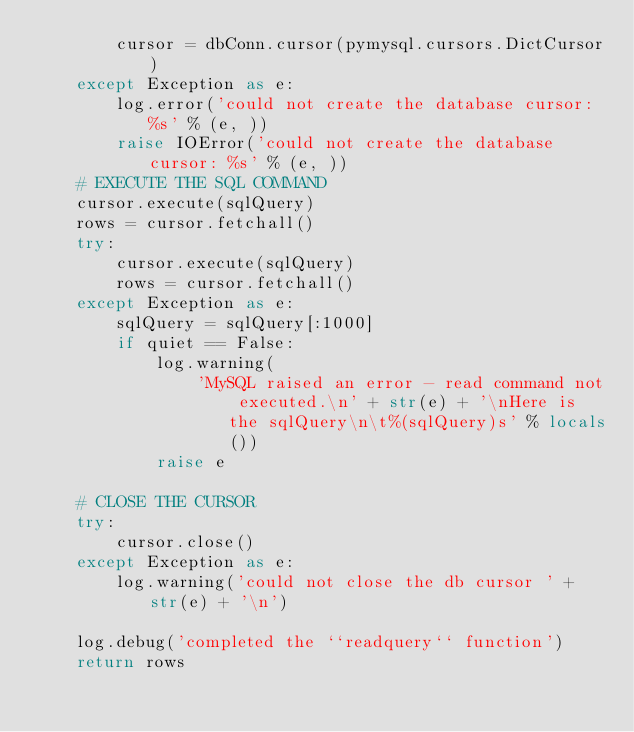<code> <loc_0><loc_0><loc_500><loc_500><_Python_>        cursor = dbConn.cursor(pymysql.cursors.DictCursor)
    except Exception as e:
        log.error('could not create the database cursor: %s' % (e, ))
        raise IOError('could not create the database cursor: %s' % (e, ))
    # EXECUTE THE SQL COMMAND
    cursor.execute(sqlQuery)
    rows = cursor.fetchall()
    try:
        cursor.execute(sqlQuery)
        rows = cursor.fetchall()
    except Exception as e:
        sqlQuery = sqlQuery[:1000]
        if quiet == False:
            log.warning(
                'MySQL raised an error - read command not executed.\n' + str(e) + '\nHere is the sqlQuery\n\t%(sqlQuery)s' % locals())
            raise e

    # CLOSE THE CURSOR
    try:
        cursor.close()
    except Exception as e:
        log.warning('could not close the db cursor ' + str(e) + '\n')

    log.debug('completed the ``readquery`` function')
    return rows
</code> 